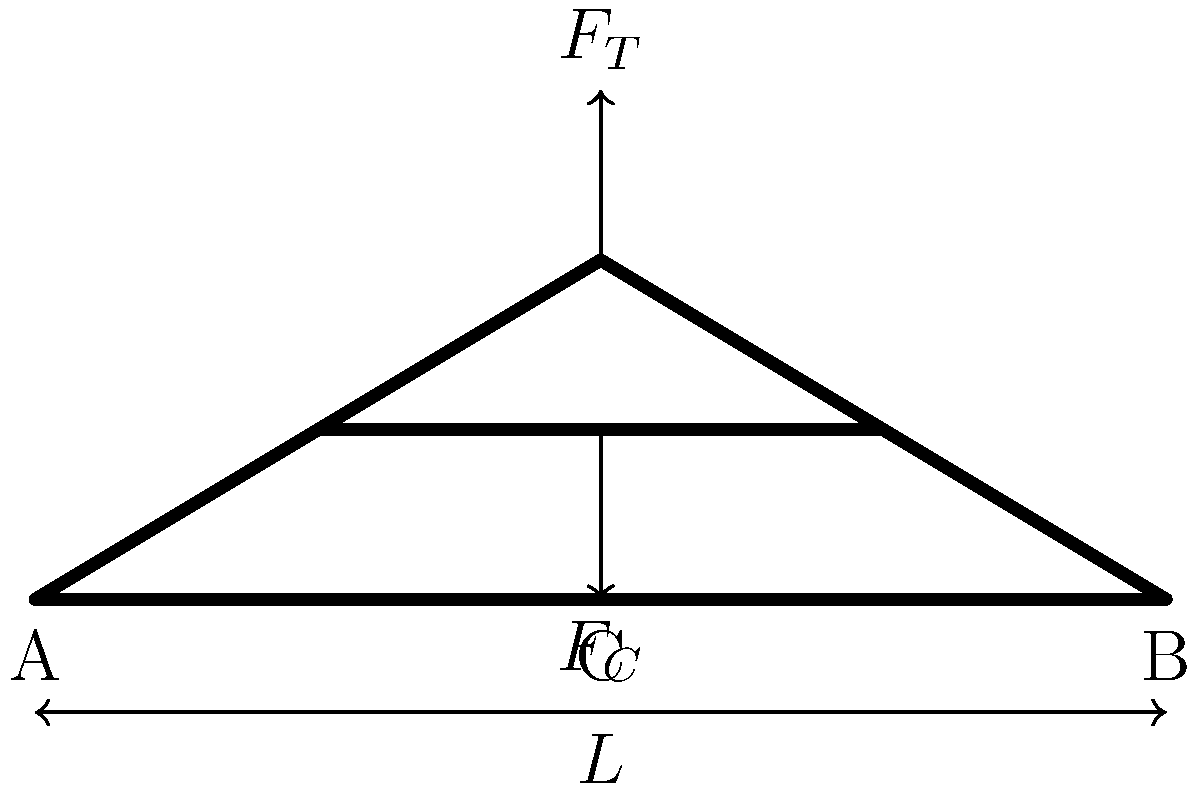Consider the iconic truss bridge design shown above, commonly used in historical constructions. If the total load $F_T$ applied at the center of the bridge is 1000 kN and the span length $L$ is 50 meters, what is the compressive force $F_C$ experienced by the bottom chord at point C? Assume the truss is symmetrical and ignore the weight of the bridge itself. To solve this problem, we'll follow these steps:

1) First, recognize that this is a simple truss bridge with a triangular design. The load $F_T$ at the top vertex creates compressive forces in the bottom chord.

2) Due to symmetry, we can consider half of the bridge. The reaction force at each support (A and B) will be half of the total load:

   $R_A = R_B = \frac{F_T}{2} = \frac{1000 \text{ kN}}{2} = 500 \text{ kN}$

3) Now, we need to find the angle θ between the diagonal member and the horizontal:

   $\tan \theta = \frac{\text{height}}{\text{half-span}} = \frac{30}{50/2} = \frac{30}{25} = 1.2$
   
   $\theta = \arctan(1.2) \approx 50.2°$

4) The compressive force in the bottom chord ($F_C$) can be found by resolving the forces at point C:

   $F_C = \frac{R_A}{\tan \theta} = \frac{500 \text{ kN}}{\tan 50.2°} \approx 417 \text{ kN}$

5) However, this is only half of the total compressive force. Since the bridge is symmetrical, the total compressive force in the bottom chord at point C is:

   $F_C(\text{total}) = 2 \times 417 \text{ kN} = 834 \text{ kN}$

Therefore, the compressive force experienced by the bottom chord at point C is approximately 834 kN.
Answer: 834 kN 